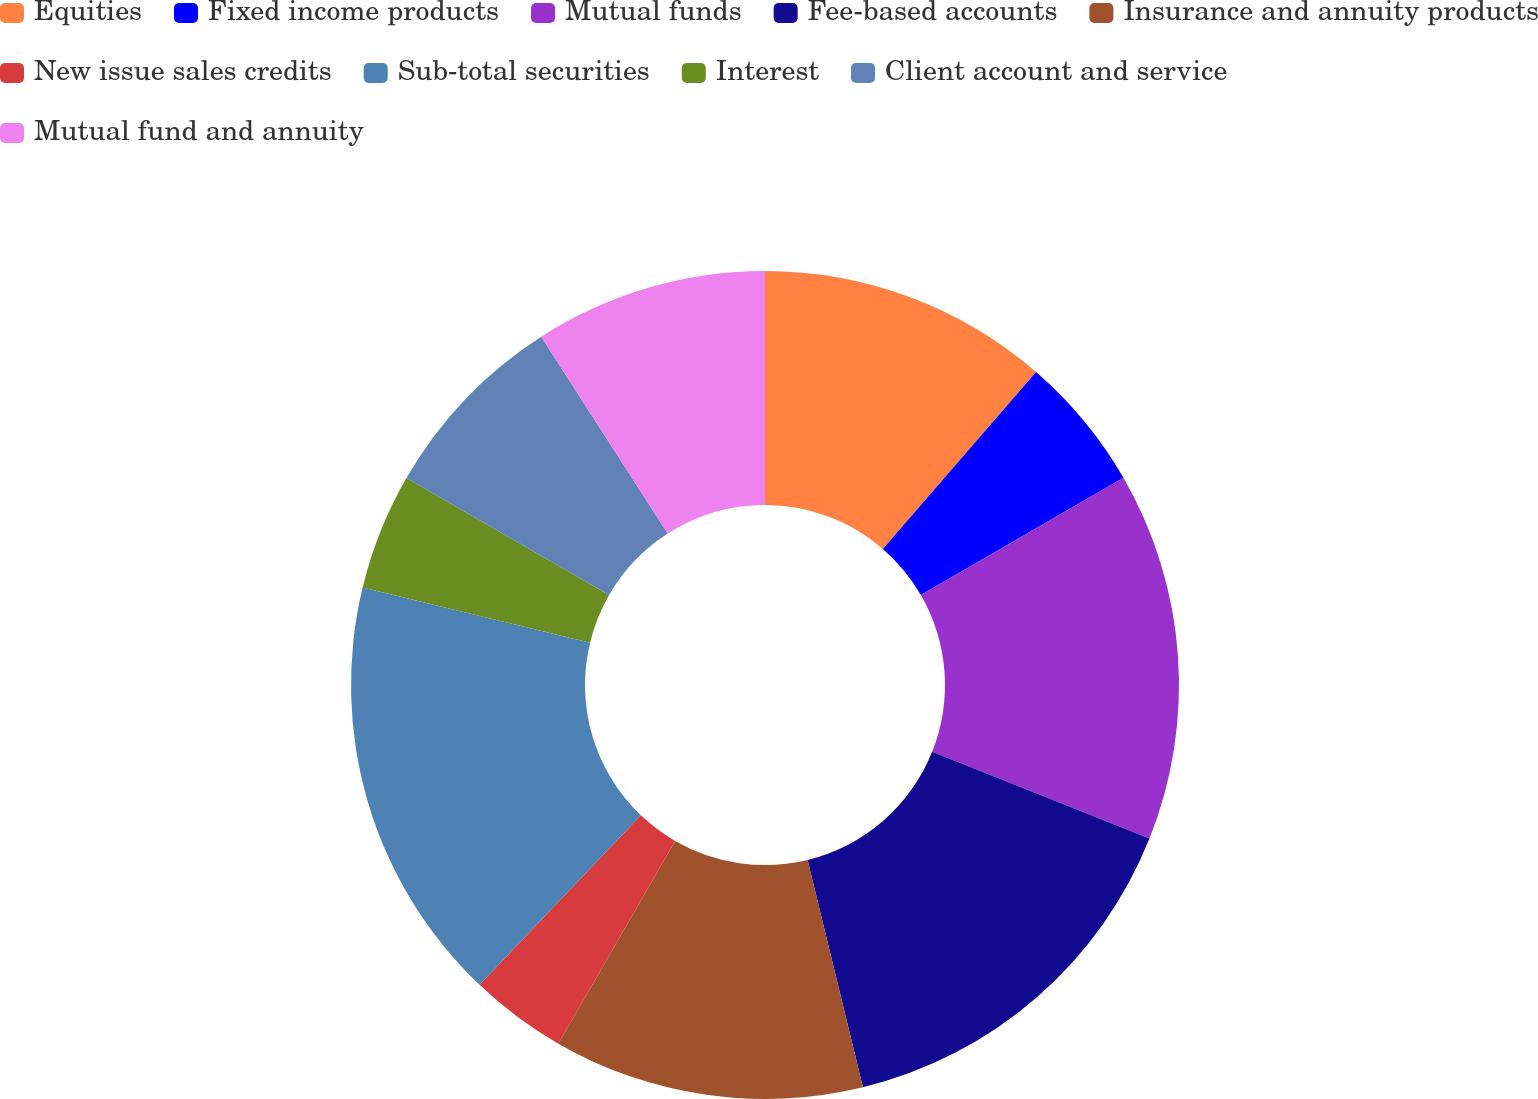Convert chart. <chart><loc_0><loc_0><loc_500><loc_500><pie_chart><fcel>Equities<fcel>Fixed income products<fcel>Mutual funds<fcel>Fee-based accounts<fcel>Insurance and annuity products<fcel>New issue sales credits<fcel>Sub-total securities<fcel>Interest<fcel>Client account and service<fcel>Mutual fund and annuity<nl><fcel>11.36%<fcel>5.3%<fcel>14.39%<fcel>15.15%<fcel>12.12%<fcel>3.79%<fcel>16.67%<fcel>4.55%<fcel>7.58%<fcel>9.09%<nl></chart> 